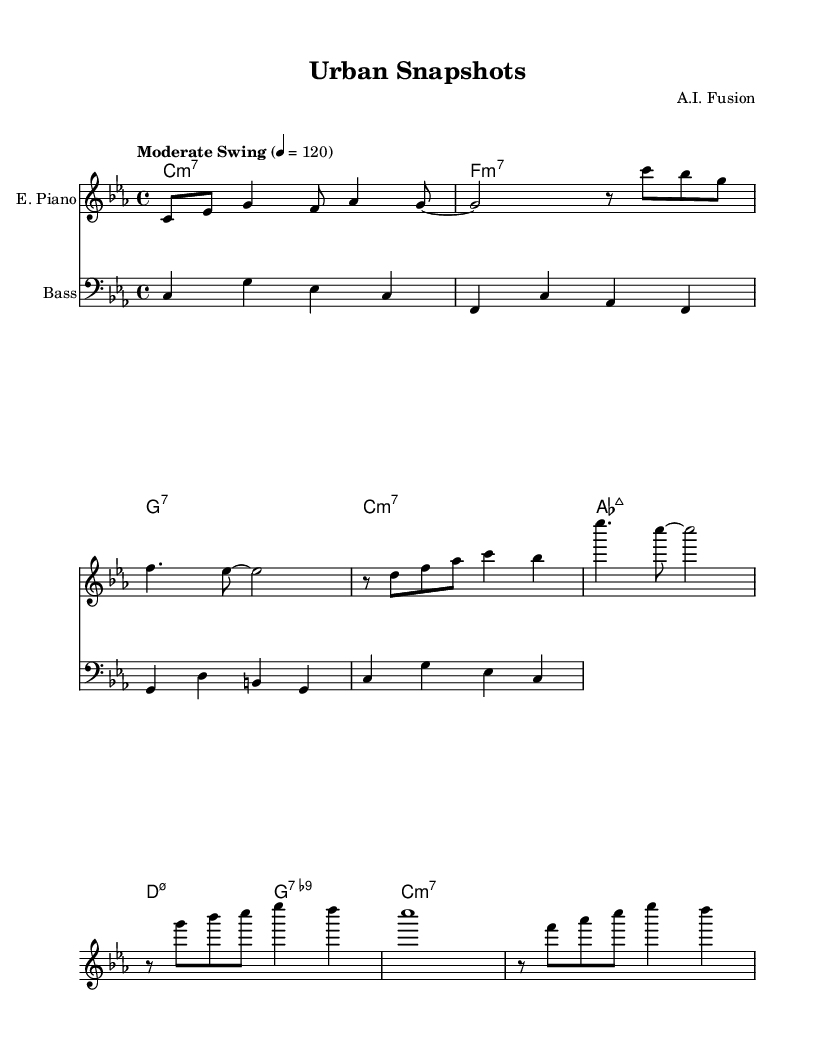What is the key signature of this music? The key signature is C minor, indicated by three flats in the key signature.
Answer: C minor What is the time signature of this music? The time signature is shown as 4/4, meaning there are four beats in each measure and the quarter note gets one beat.
Answer: 4/4 What is the tempo marking of this piece? The tempo marking states "Moderate Swing" with a metronome marking of 120 beats per minute, indicating a relaxed swing feel.
Answer: Moderate Swing How many measures are in the main theme section? Counting the measures in the electric piano part, there are a total of 8 measures in the main theme before the bridge starts.
Answer: 8 measures What type of chord is indicated in the first measure? The first measure features a C minor seventh chord, denoted by the "C:m7" chord symbol.
Answer: C:m7 How does the bass guitar support the chord changes? The bass guitar plays a simplified walking bass line that outlines the root notes corresponding to the chord changes, helping to establish the harmonic foundation.
Answer: Root notes What musical style does this piece represent? The piece reflects elements of jazz fusion, combining improvisation and a blend of musical styles, akin to the spontaneity found in urban street photography.
Answer: Jazz fusion 